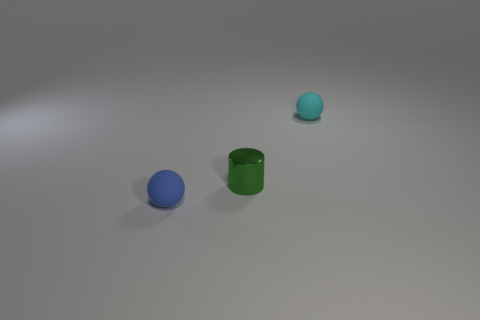What size is the sphere to the right of the tiny blue matte object?
Ensure brevity in your answer.  Small. What is the material of the cyan object?
Offer a terse response. Rubber. What is the shape of the matte object that is to the left of the tiny cyan ball to the right of the small cylinder?
Keep it short and to the point. Sphere. What number of other things are the same shape as the tiny green object?
Provide a short and direct response. 0. Are there any matte objects right of the small green shiny thing?
Offer a very short reply. Yes. What is the color of the tiny metal object?
Your answer should be compact. Green. Are there any blue cubes that have the same size as the cyan rubber ball?
Ensure brevity in your answer.  No. What material is the ball that is left of the cyan matte sphere?
Provide a succinct answer. Rubber. Are there an equal number of cyan balls that are on the right side of the small green cylinder and green metal cylinders that are to the right of the cyan ball?
Provide a succinct answer. No. Is the size of the matte thing that is right of the tiny blue thing the same as the rubber object in front of the cyan sphere?
Offer a very short reply. Yes. 